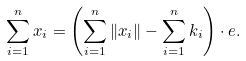<formula> <loc_0><loc_0><loc_500><loc_500>\sum _ { i = 1 } ^ { n } x _ { i } = \left ( \sum _ { i = 1 } ^ { n } \left \| x _ { i } \right \| - \sum _ { i = 1 } ^ { n } k _ { i } \right ) \cdot e .</formula> 